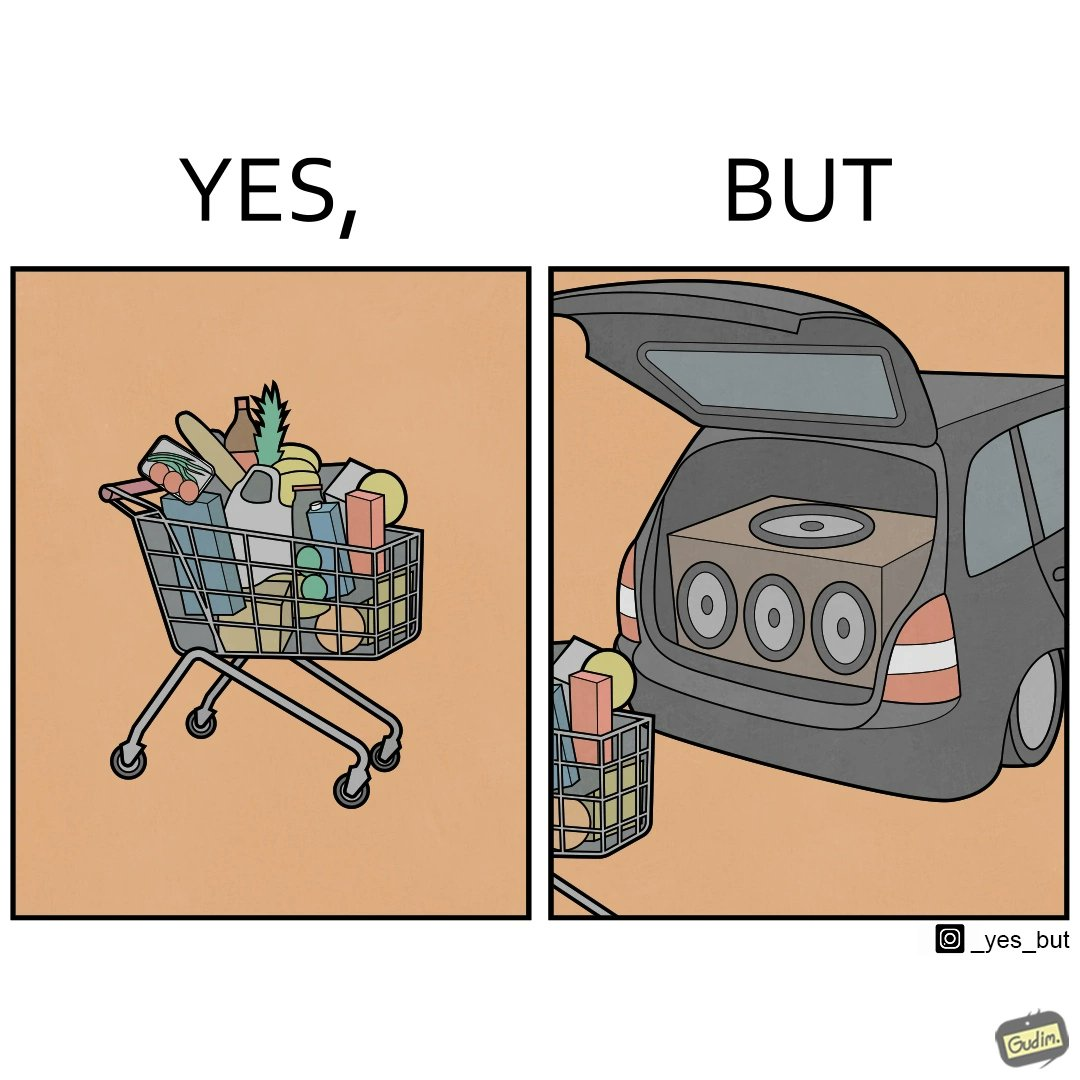What is the satirical meaning behind this image? The image is ironic, because a car trunk was earlier designed to keep some extra luggage or things but people nowadays get speakers installed in the trunk which in turn reduces the space in the trunk and making it difficult for people to store the extra luggage in the trunk 